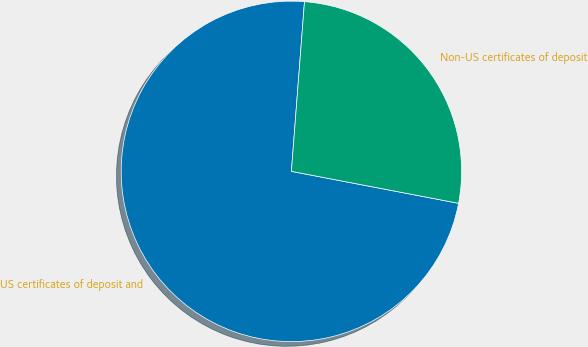Convert chart. <chart><loc_0><loc_0><loc_500><loc_500><pie_chart><fcel>US certificates of deposit and<fcel>Non-US certificates of deposit<nl><fcel>73.22%<fcel>26.78%<nl></chart> 